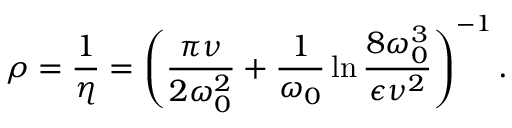Convert formula to latex. <formula><loc_0><loc_0><loc_500><loc_500>\rho = \frac { 1 } { \eta } = \left ( \frac { \pi \nu } { 2 \omega _ { 0 } ^ { 2 } } + \frac { 1 } { \omega _ { 0 } } \ln { \frac { 8 \omega _ { 0 } ^ { 3 } } { \epsilon \nu ^ { 2 } } } \right ) ^ { - 1 } .</formula> 